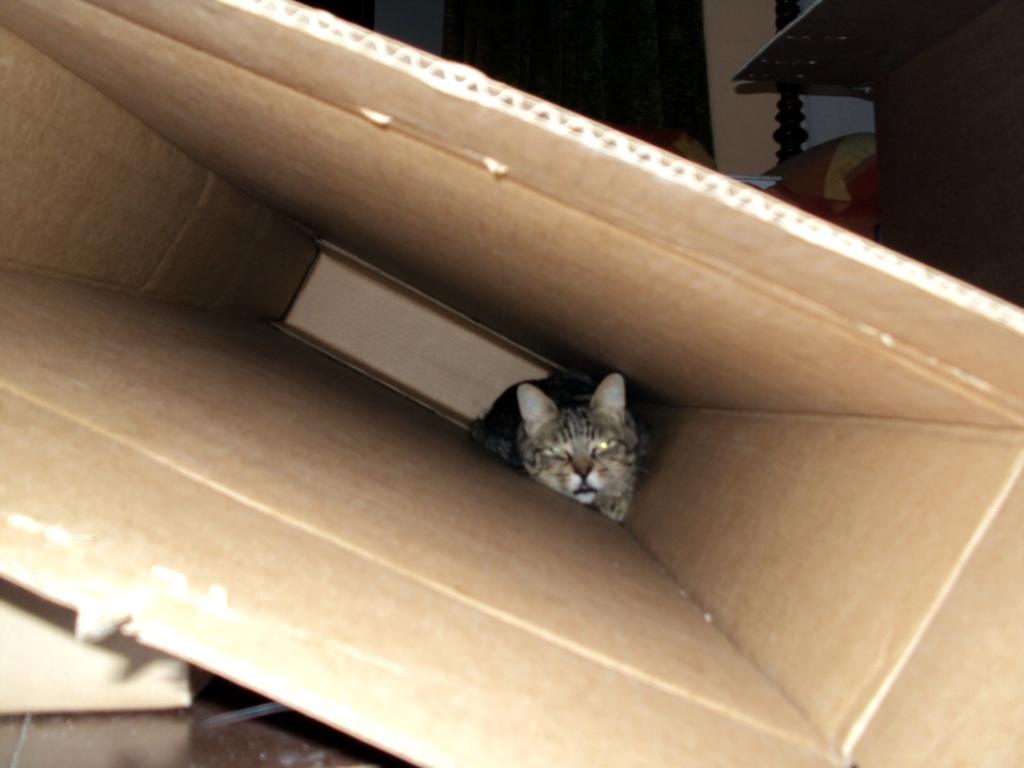What type of animal is in the image? There is a kitten in the image. Where is the kitten located? The kitten is inside a carton box. What can be seen in the background of the image? There is a surface, a wall, a door, a cushion, and a pole visible in the top part of the image. What type of fruit is the kitten holding in its mouth? The kitten is not holding any fruit in its mouth; it is inside a carton box. How many fangs does the kitten have in the image? Kittens do not have fangs like some other animals; they have teeth adapted for their diet. 